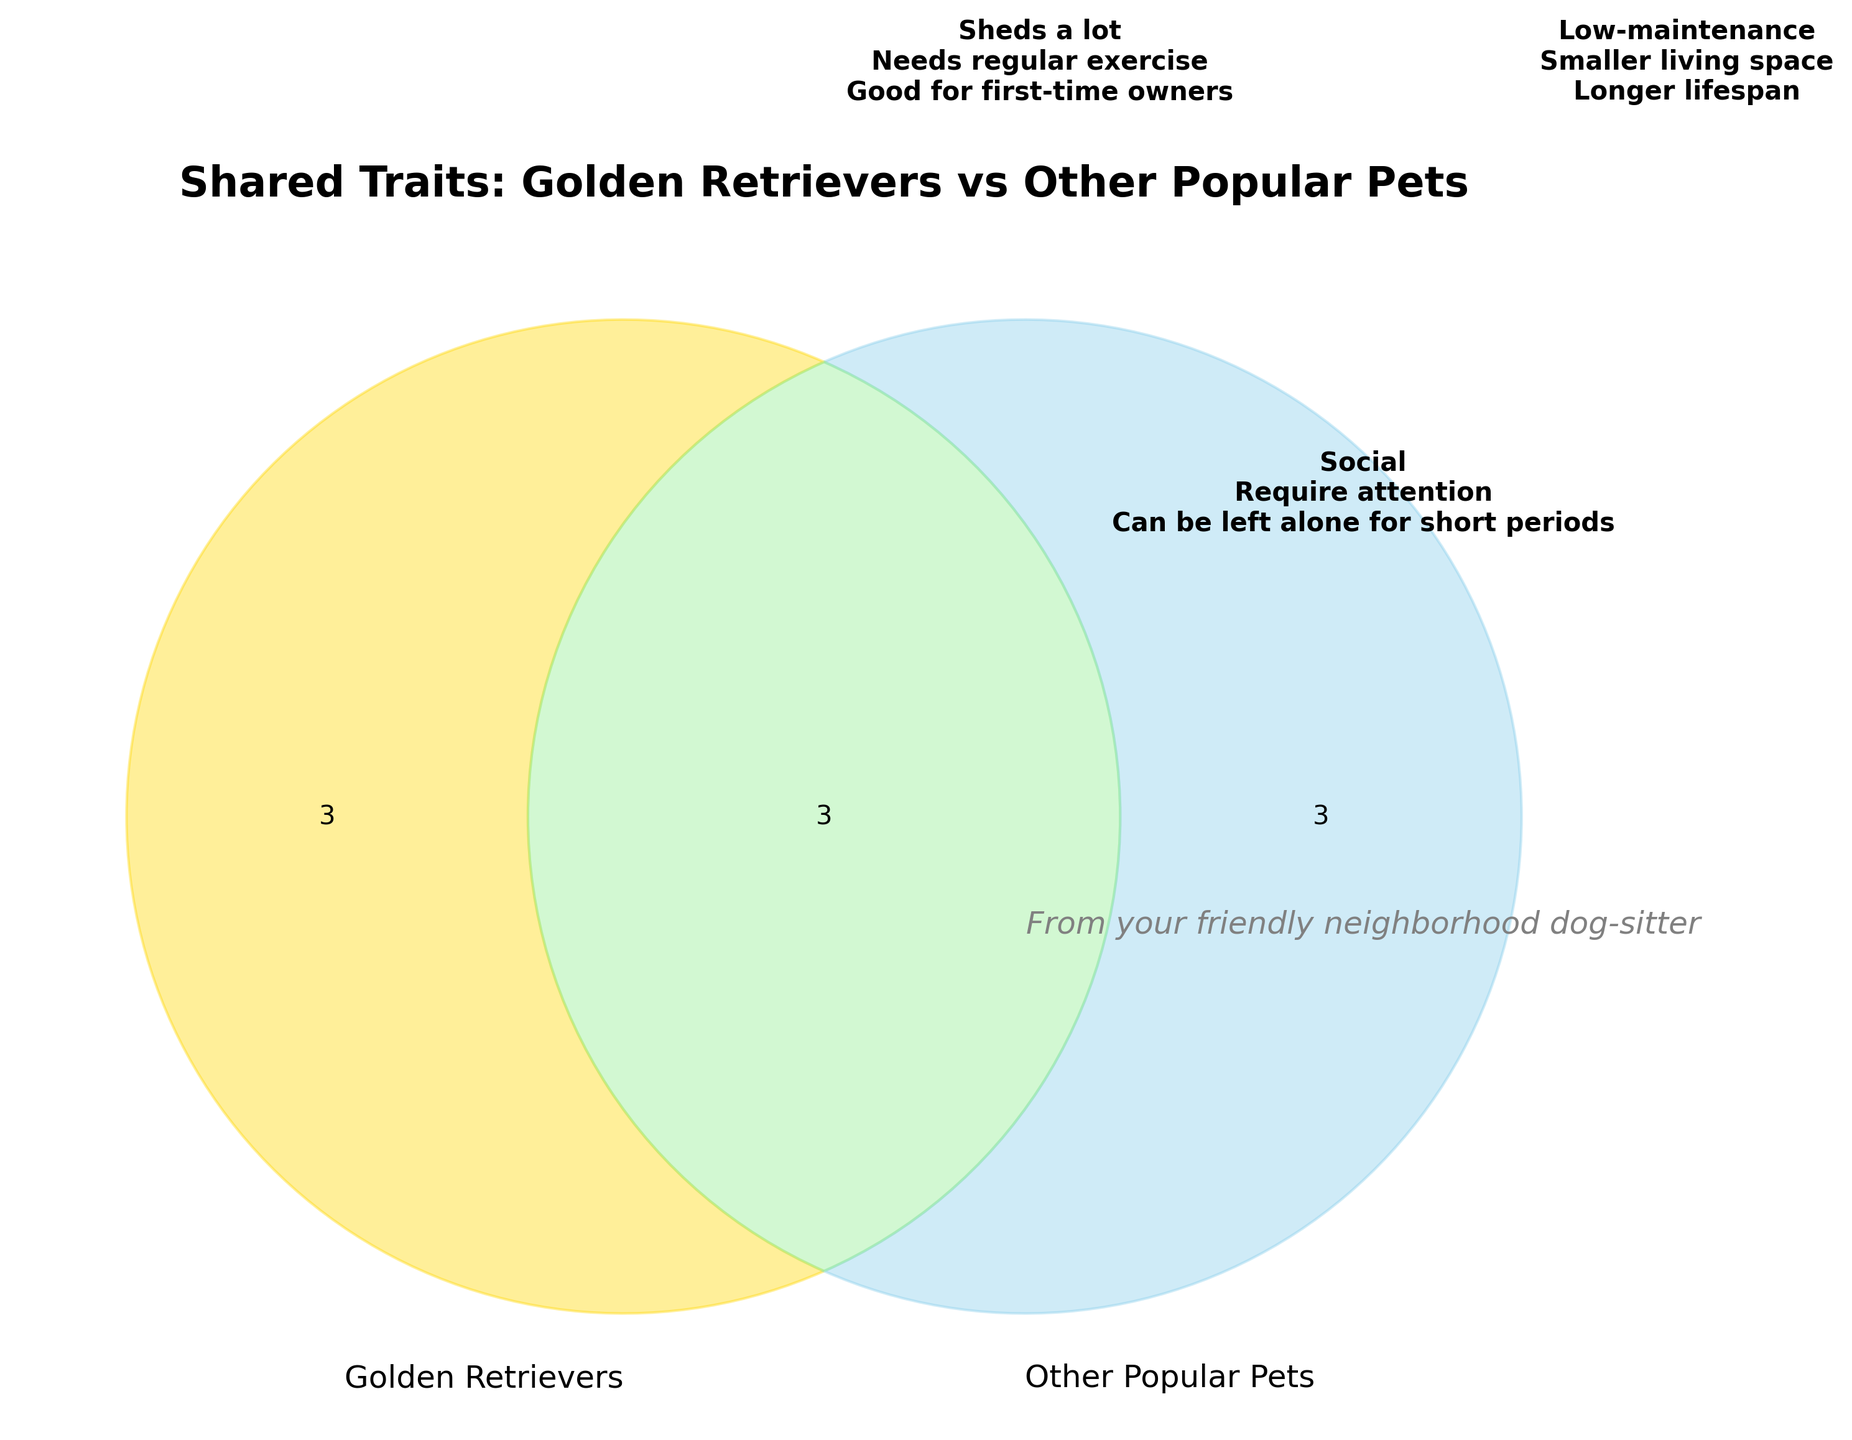What is the title of the figure? The title of the figure is written prominently at the top of the plot. It reads, "Shared Traits: Golden Retrievers vs Other Popular Pets".
Answer: Shared Traits: Golden Retrievers vs Other Popular Pets What color represents 'Golden Retrievers'? The 'Golden Retrievers' section of the Venn diagram is colored in a gold shade. This can be seen on the left side of the diagram.
Answer: Gold How many unique traits of Golden Retrievers are listed? The unique traits of Golden Retrievers are listed within the gold-colored section. Counting these traits gives three items: "Sheds a lot", "Needs regular exercise", and "Good for first-time owners".
Answer: Three Which trait appears in both Golden Retrievers and other popular pets? The overlapping, greenish section of the Venn diagram represents traits shared by Golden Retrievers and other popular pets. The traits listed here include: "Social" and "Require attention".
Answer: Two Which traits are unique to other popular pets and not shared by Golden Retrievers? The other popular pets section, colored in light blue, lists traits that include "Low-maintenance", "Smaller living space", and "Longer lifespan".
Answer: Low-maintenance, Smaller living space, Longer lifespan Does the figure mention if Golden Retrievers can be left alone for short periods? The figure includes this trait in the overlapping section, indicating that both Golden Retrievers and other popular pets can be left alone for short periods.
Answer: Yes Which section of the figure is the largest? To determine the largest section, we consider the number of traits listed in each section. Both the sections for only Golden Retrievers and only other popular pets have three traits each, while the shared section has three traits as well. Hence, all sections are equally sized in terms of the number of traits listed.
Answer: Equal Which section mentions traits about smaller living space and longer lifespan? The section on the right, specifically for other popular pets and colored light blue, lists both "Smaller living space" and "Longer lifespan".
Answer: Other popular pets 